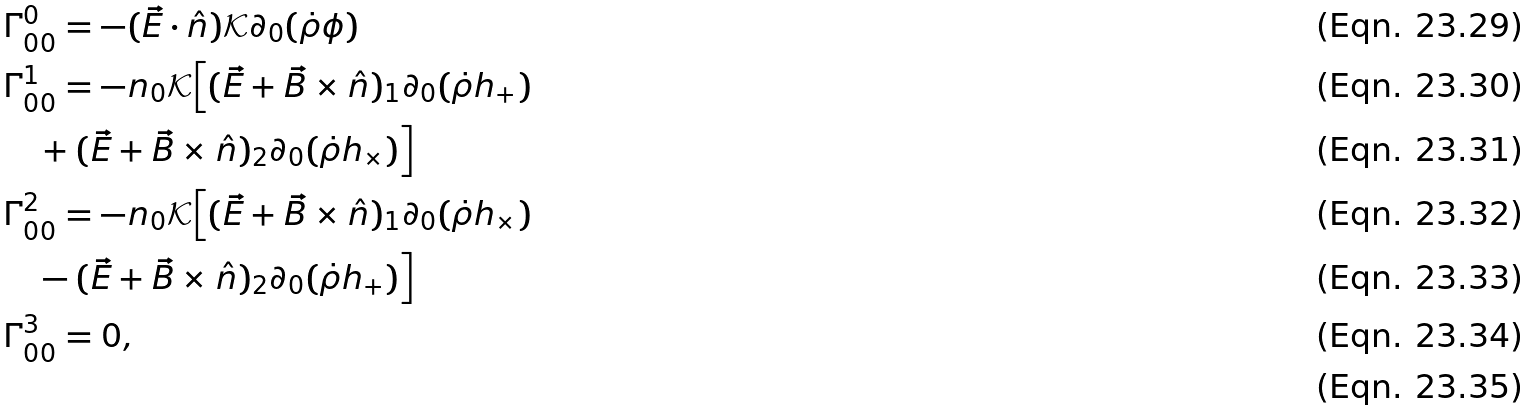Convert formula to latex. <formula><loc_0><loc_0><loc_500><loc_500>& \Gamma ^ { 0 } _ { 0 0 } = - ( \vec { E } \cdot \hat { n } ) \mathcal { K } \partial _ { 0 } ( \dot { \rho } \phi ) \\ & \Gamma ^ { 1 } _ { 0 0 } = - n _ { 0 } \mathcal { K } \Big { [ } ( \vec { E } + \vec { B } \times \hat { n } ) _ { 1 } \partial _ { 0 } ( \dot { \rho } h _ { + } ) \\ & \quad + ( \vec { E } + \vec { B } \times \hat { n } ) _ { 2 } \partial _ { 0 } ( \dot { \rho } h _ { \times } ) \Big { ] } \\ & \Gamma ^ { 2 } _ { 0 0 } = - n _ { 0 } \mathcal { K } \Big { [ } ( \vec { E } + \vec { B } \times \hat { n } ) _ { 1 } \partial _ { 0 } ( \dot { \rho } h _ { \times } ) \\ & \quad - ( \vec { E } + \vec { B } \times \hat { n } ) _ { 2 } \partial _ { 0 } ( \dot { \rho } h _ { + } ) \Big { ] } \\ & \Gamma ^ { 3 } _ { 0 0 } = 0 , \\</formula> 